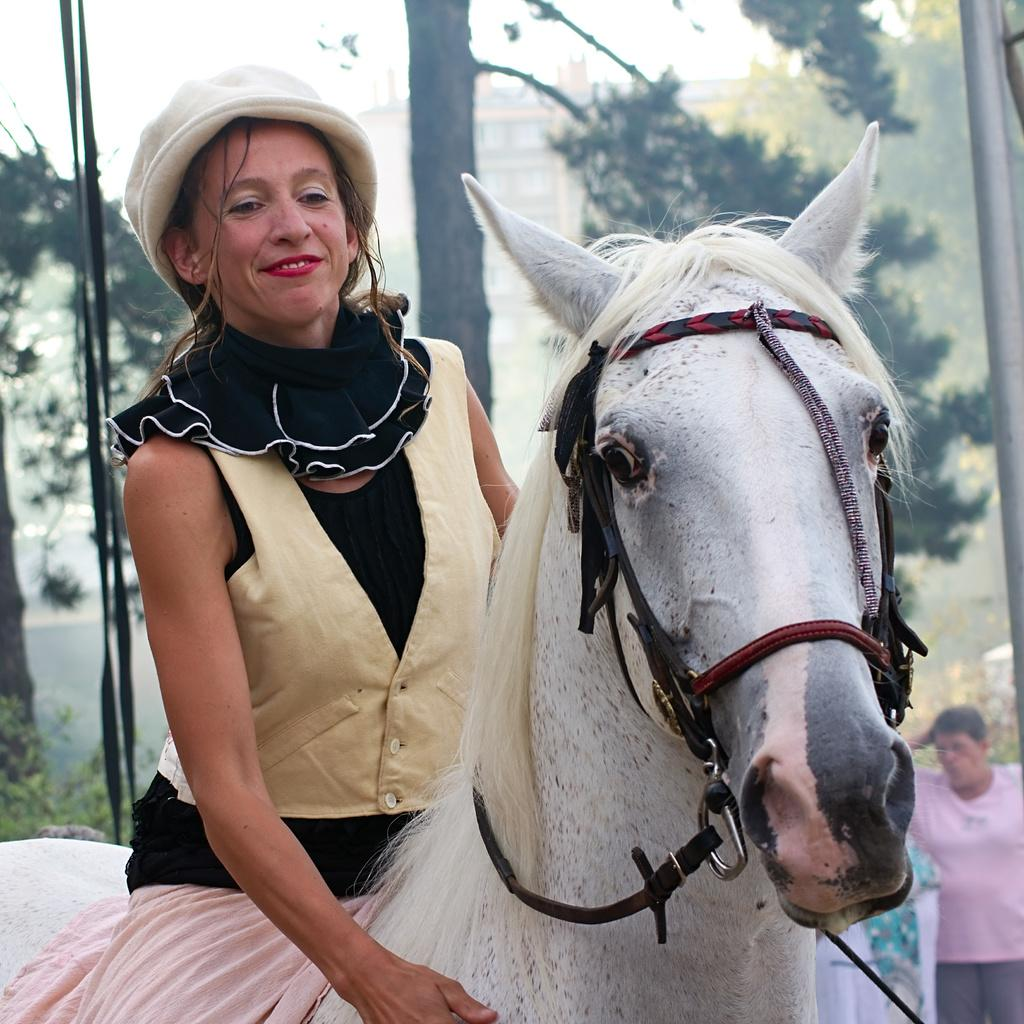What is the woman in the image doing? The woman is sitting on a horse. Can you describe the background of the image? There is a man, a tree, and a building in the background. Where is the man located in the image? The man is in the background on the right side. What type of coil is being used by the woman to control the horse in the image? There is no coil present in the image; the woman is sitting on the horse without any visible reins or coils. 